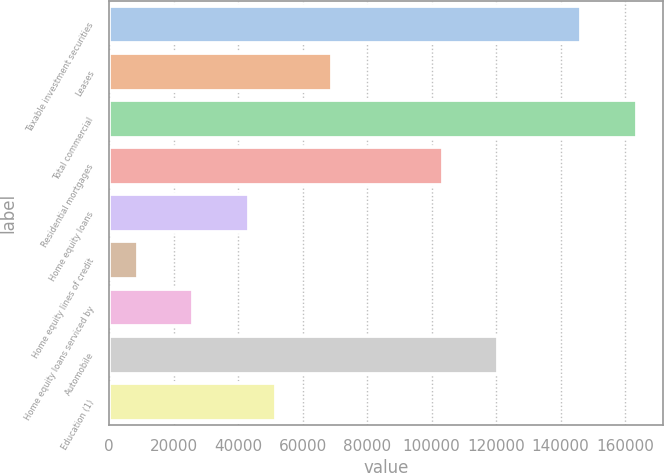<chart> <loc_0><loc_0><loc_500><loc_500><bar_chart><fcel>Taxable investment securities<fcel>Leases<fcel>Total commercial<fcel>Residential mortgages<fcel>Home equity loans<fcel>Home equity lines of credit<fcel>Home equity loans serviced by<fcel>Automobile<fcel>Education (1)<nl><fcel>146424<fcel>69065<fcel>163616<fcel>103447<fcel>43278.5<fcel>8896.5<fcel>26087.5<fcel>120638<fcel>51874<nl></chart> 